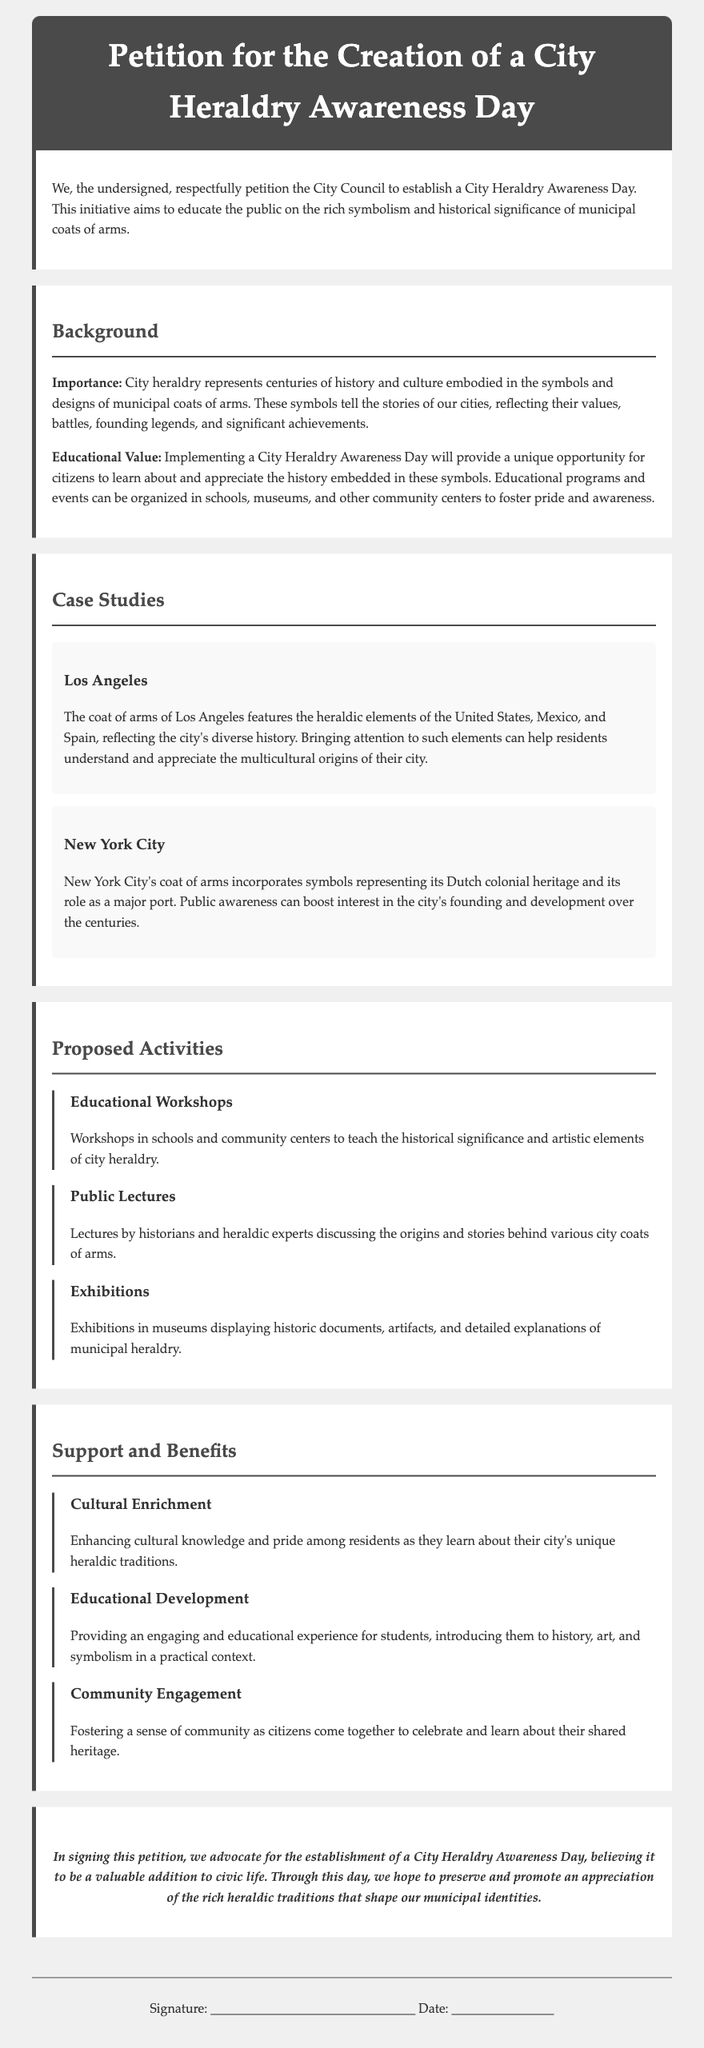What is the title of the petition? The title is the heading of the document which indicates the purpose of the petition.
Answer: Petition for the Creation of a City Heraldry Awareness Day What is the primary aim of the petition? The aim is stated clearly in the opening paragraph of the document.
Answer: To educate the public on the rich symbolism and historical significance of municipal coats of arms Which city’s coat of arms features elements of the United States, Mexico, and Spain? This specific information is provided in the case study section of the document.
Answer: Los Angeles How many proposed activities are listed in the document? The document explicitly enumerates the activities in a section dedicated to this purpose.
Answer: Three What benefit relates to enhancing cultural knowledge among residents? This is a specific benefit outlined in the support and benefits section of the document.
Answer: Cultural Enrichment Who would potentially lead the public lectures mentioned in the proposed activities? This information can be inferred from the discussion of the activities proposed in the document.
Answer: Historians and heraldic experts What type of educational programs does the document suggest for schools? The document describes the nature of proposed programs aimed at educational institutions.
Answer: Educational Workshops 